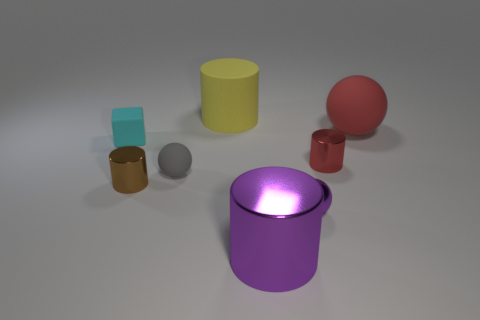Add 2 purple matte spheres. How many objects exist? 10 Subtract all cubes. How many objects are left? 7 Subtract 0 yellow balls. How many objects are left? 8 Subtract all blocks. Subtract all small red cylinders. How many objects are left? 6 Add 6 big metallic objects. How many big metallic objects are left? 7 Add 3 brown metal blocks. How many brown metal blocks exist? 3 